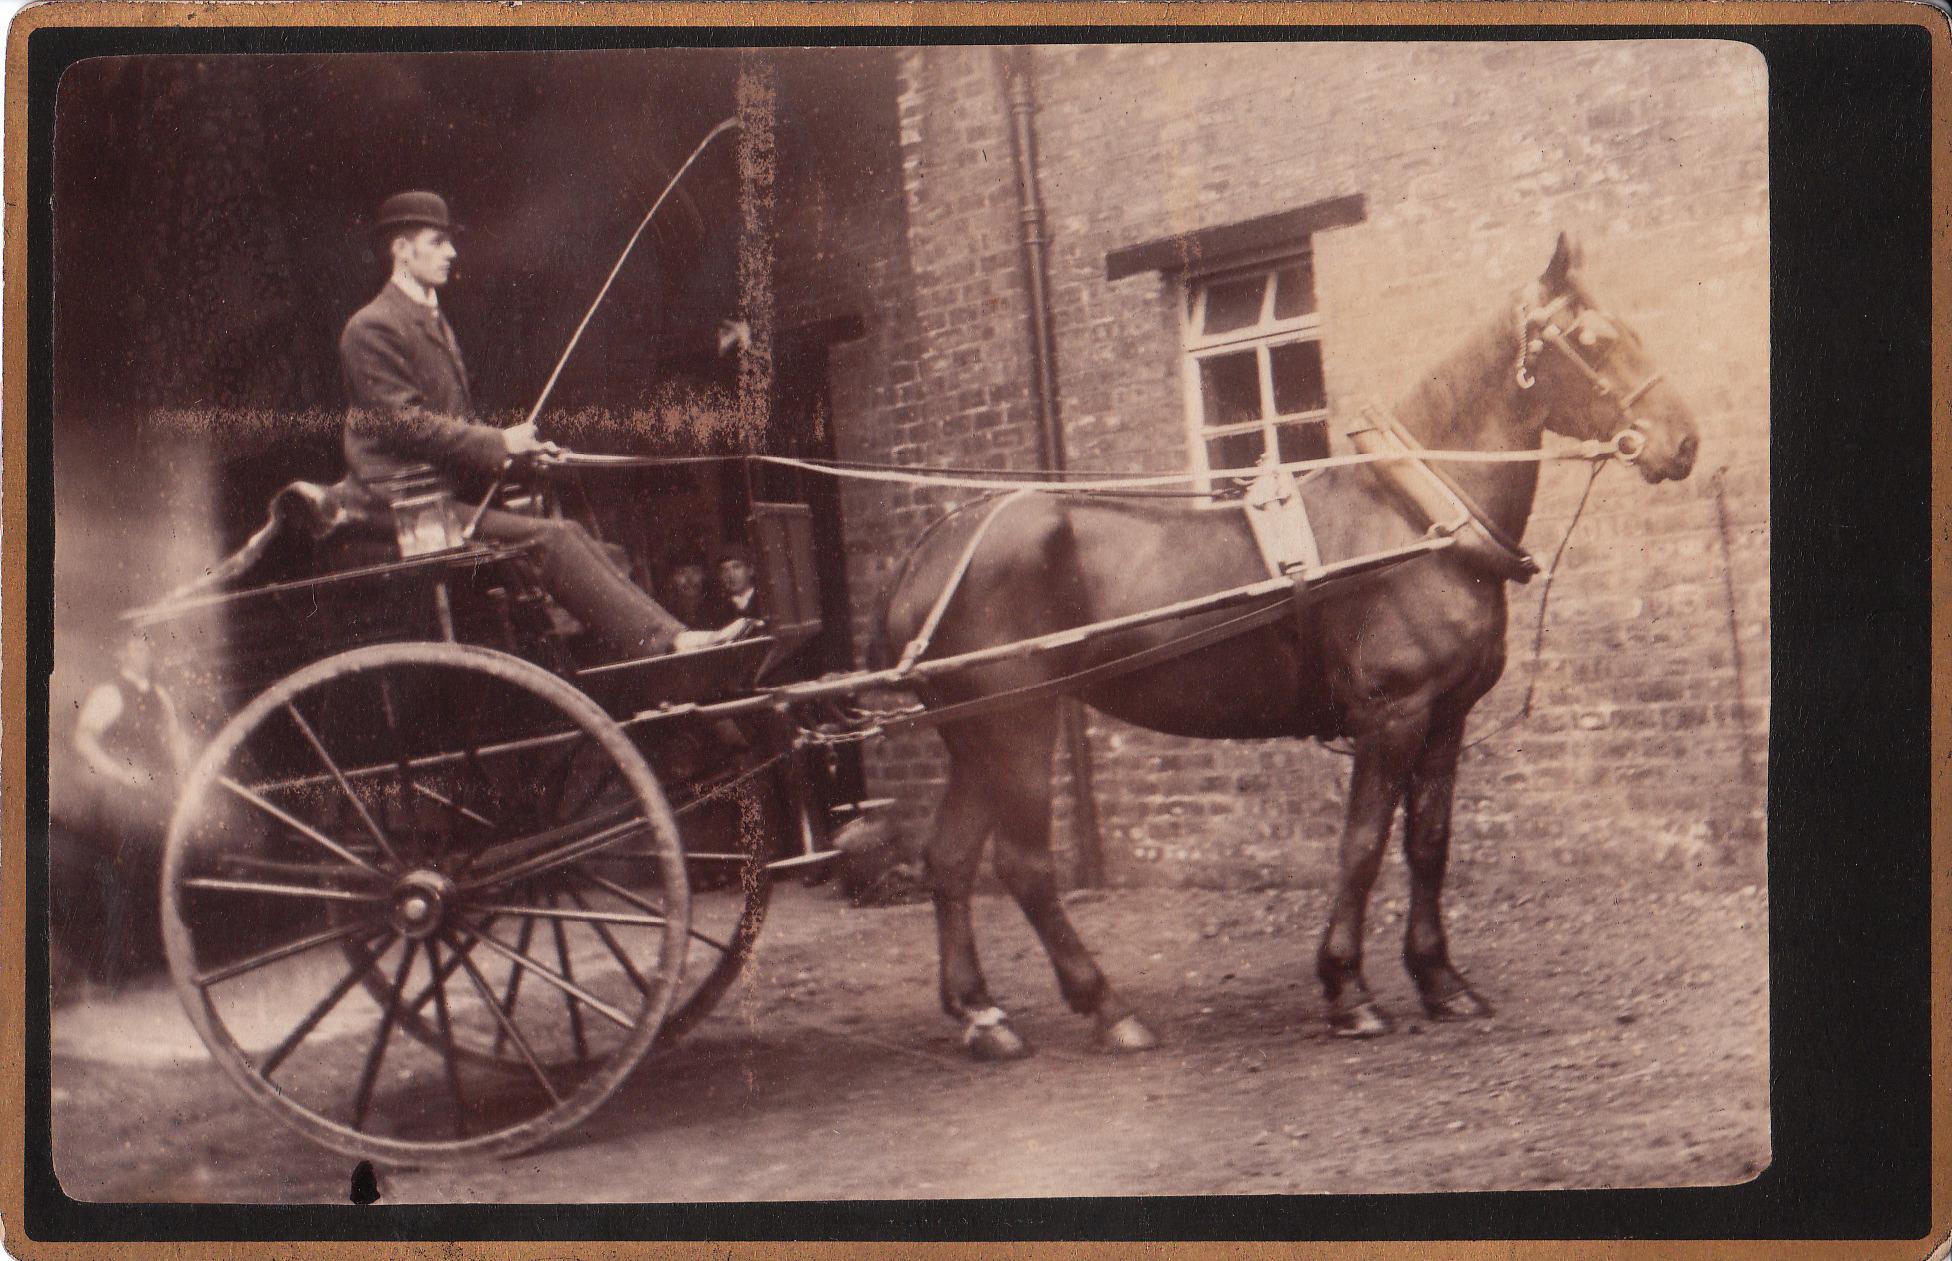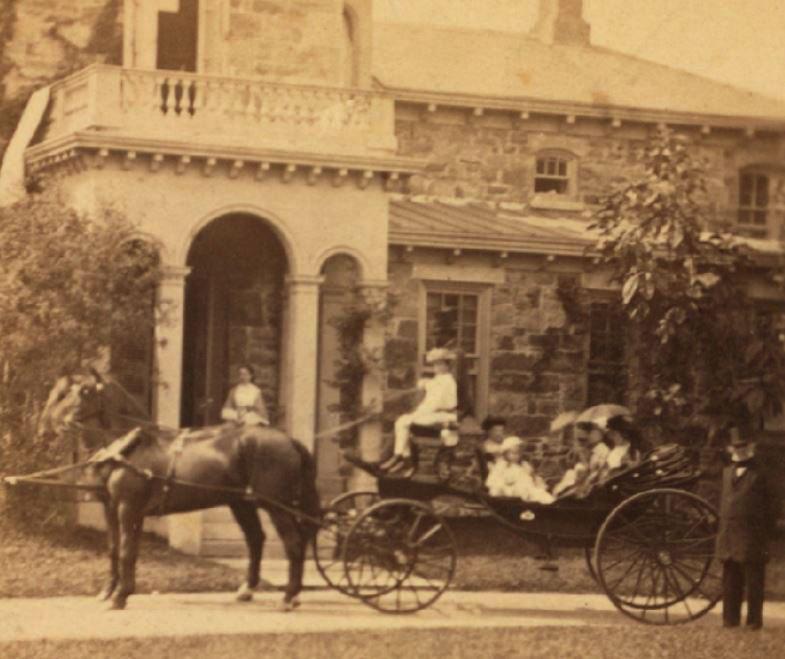The first image is the image on the left, the second image is the image on the right. Considering the images on both sides, is "A man sits on a horse wagon that has only 2 wheels." valid? Answer yes or no. Yes. 